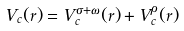<formula> <loc_0><loc_0><loc_500><loc_500>V _ { c } ( r ) = V _ { c } ^ { \sigma + \omega } ( r ) + V _ { c } ^ { \rho } ( r )</formula> 